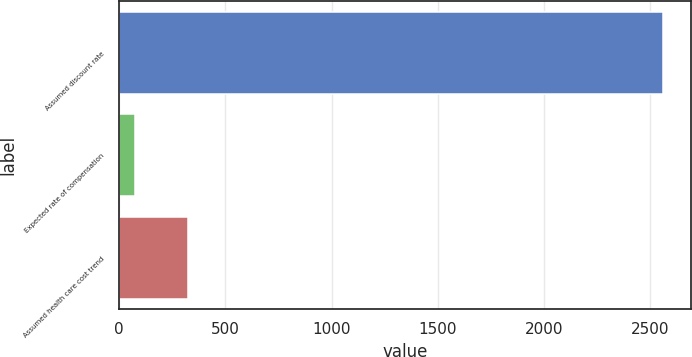Convert chart. <chart><loc_0><loc_0><loc_500><loc_500><bar_chart><fcel>Assumed discount rate<fcel>Expected rate of compensation<fcel>Assumed health care cost trend<nl><fcel>2561<fcel>77<fcel>325.4<nl></chart> 